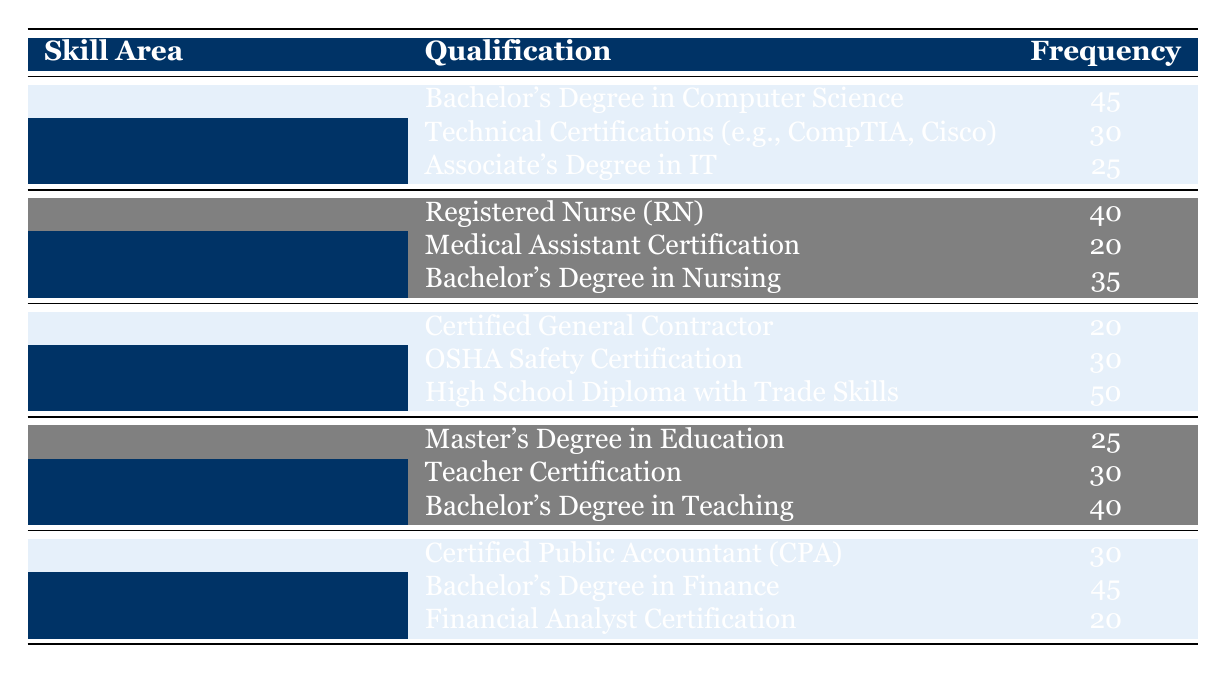What is the highest frequency qualification in the Information Technology skill area? The qualification with the highest frequency under the Information Technology skill area is "Bachelor's Degree in Computer Science," which has a frequency of 45.
Answer: 45 How many total qualifications are listed under the Healthcare skill area? There are three qualifications listed under the Healthcare skill area: Registered Nurse (RN), Medical Assistant Certification, and Bachelor's Degree in Nursing. Therefore, the total is 3.
Answer: 3 What is the total frequency of qualifications in the Construction skill area? The frequencies for the Construction skill area are: Certified General Contractor (20), OSHA Safety Certification (30), and High School Diploma with Trade Skills (50). Summing these gives 20 + 30 + 50 = 100.
Answer: 100 Is there a qualification listed under the Finance skill area with a frequency of 45? Yes, the qualification "Bachelor's Degree in Finance" has a frequency of 45, indicating that there is indeed such a qualification.
Answer: Yes What is the average frequency of qualifications in the Education skill area? The frequencies for Education qualifications are: Master's Degree in Education (25), Teacher Certification (30), and Bachelor's Degree in Teaching (40). The sum is 25 + 30 + 40 = 95, and dividing by the 3 qualifications gives an average of 95 / 3 ≈ 31.67.
Answer: 31.67 